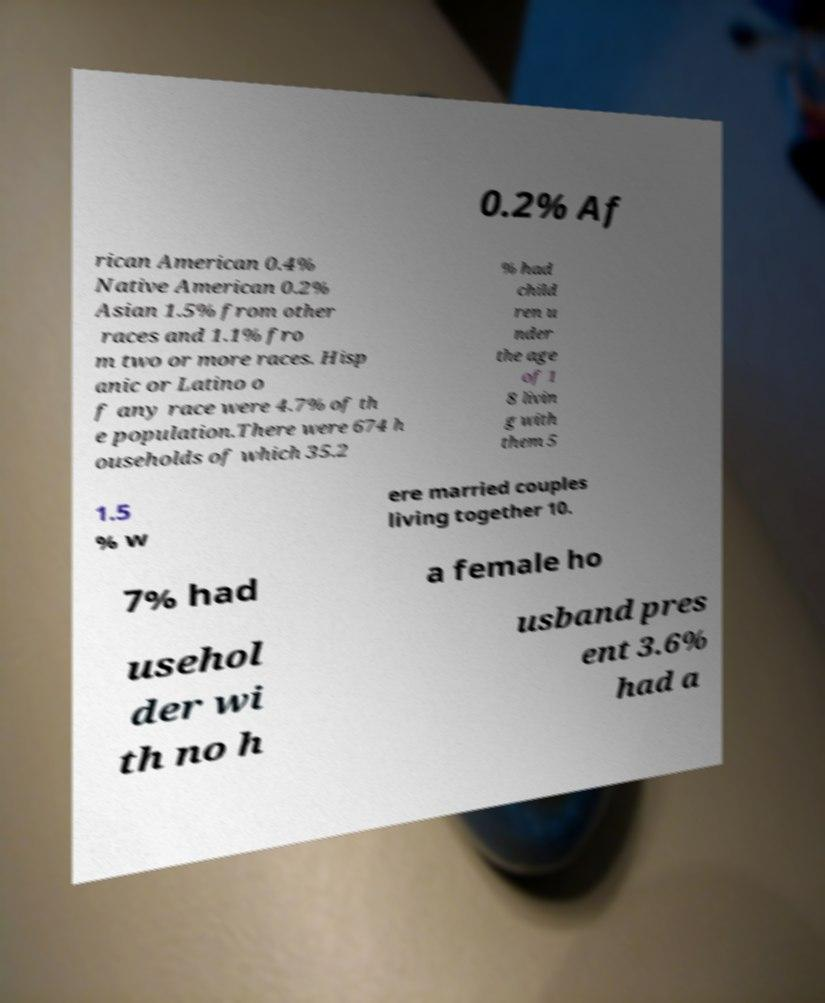I need the written content from this picture converted into text. Can you do that? 0.2% Af rican American 0.4% Native American 0.2% Asian 1.5% from other races and 1.1% fro m two or more races. Hisp anic or Latino o f any race were 4.7% of th e population.There were 674 h ouseholds of which 35.2 % had child ren u nder the age of 1 8 livin g with them 5 1.5 % w ere married couples living together 10. 7% had a female ho usehol der wi th no h usband pres ent 3.6% had a 